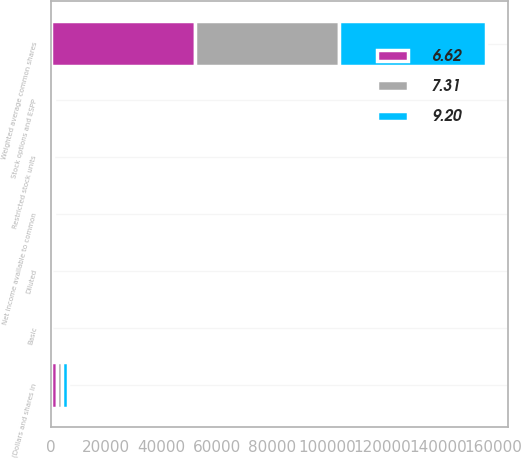Convert chart to OTSL. <chart><loc_0><loc_0><loc_500><loc_500><stacked_bar_chart><ecel><fcel>(Dollars and shares in<fcel>Net income available to common<fcel>Weighted average common shares<fcel>Stock options and ESPP<fcel>Restricted stock units<fcel>Basic<fcel>Diluted<nl><fcel>9.2<fcel>2017<fcel>385<fcel>53306<fcel>385<fcel>333<fcel>9.33<fcel>9.2<nl><fcel>7.31<fcel>2016<fcel>385<fcel>52349<fcel>254<fcel>180<fcel>7.37<fcel>7.31<nl><fcel>6.62<fcel>2015<fcel>385<fcel>51916<fcel>387<fcel>211<fcel>6.7<fcel>6.62<nl></chart> 